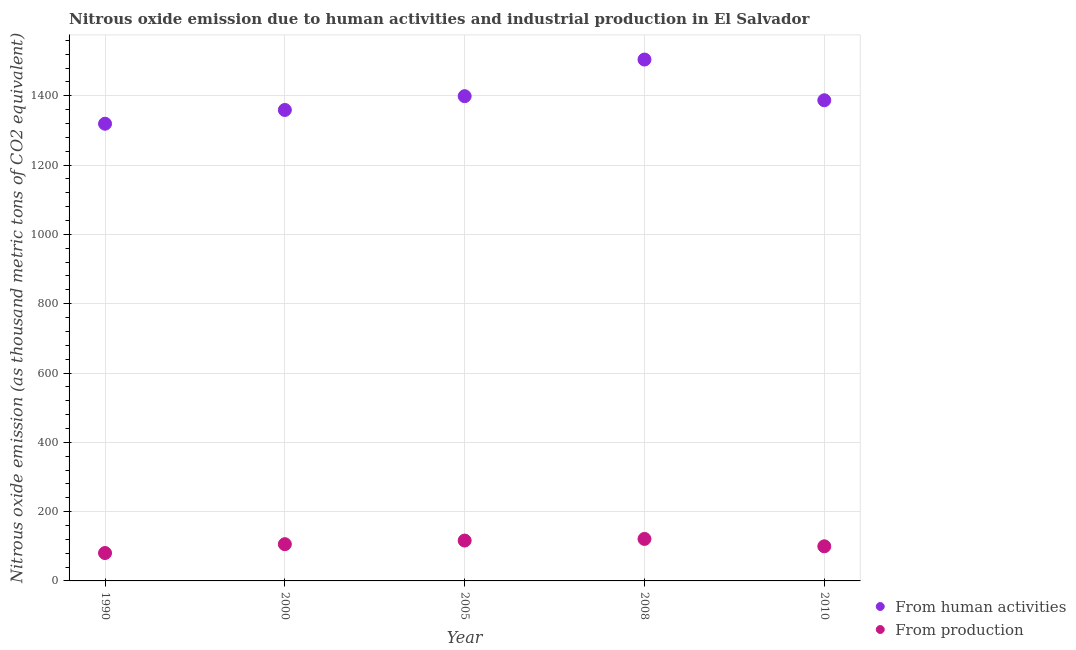Is the number of dotlines equal to the number of legend labels?
Provide a succinct answer. Yes. What is the amount of emissions generated from industries in 2010?
Your response must be concise. 99.9. Across all years, what is the maximum amount of emissions generated from industries?
Make the answer very short. 121.2. Across all years, what is the minimum amount of emissions generated from industries?
Make the answer very short. 80.5. In which year was the amount of emissions generated from industries minimum?
Keep it short and to the point. 1990. What is the total amount of emissions generated from industries in the graph?
Provide a succinct answer. 524.1. What is the difference between the amount of emissions from human activities in 2008 and that in 2010?
Make the answer very short. 117.5. What is the difference between the amount of emissions generated from industries in 2010 and the amount of emissions from human activities in 2008?
Ensure brevity in your answer.  -1404.7. What is the average amount of emissions generated from industries per year?
Make the answer very short. 104.82. In the year 2005, what is the difference between the amount of emissions from human activities and amount of emissions generated from industries?
Your response must be concise. 1282.4. What is the ratio of the amount of emissions generated from industries in 2005 to that in 2008?
Offer a terse response. 0.96. Is the amount of emissions from human activities in 1990 less than that in 2005?
Make the answer very short. Yes. What is the difference between the highest and the second highest amount of emissions generated from industries?
Your answer should be very brief. 4.7. What is the difference between the highest and the lowest amount of emissions from human activities?
Your answer should be very brief. 185.2. Is the sum of the amount of emissions generated from industries in 2005 and 2008 greater than the maximum amount of emissions from human activities across all years?
Offer a very short reply. No. Does the amount of emissions from human activities monotonically increase over the years?
Provide a short and direct response. No. Is the amount of emissions generated from industries strictly greater than the amount of emissions from human activities over the years?
Give a very brief answer. No. Is the amount of emissions from human activities strictly less than the amount of emissions generated from industries over the years?
Offer a terse response. No. How many dotlines are there?
Provide a short and direct response. 2. How many years are there in the graph?
Offer a terse response. 5. What is the difference between two consecutive major ticks on the Y-axis?
Provide a succinct answer. 200. Where does the legend appear in the graph?
Provide a short and direct response. Bottom right. How are the legend labels stacked?
Offer a terse response. Vertical. What is the title of the graph?
Provide a short and direct response. Nitrous oxide emission due to human activities and industrial production in El Salvador. What is the label or title of the Y-axis?
Keep it short and to the point. Nitrous oxide emission (as thousand metric tons of CO2 equivalent). What is the Nitrous oxide emission (as thousand metric tons of CO2 equivalent) in From human activities in 1990?
Your response must be concise. 1319.4. What is the Nitrous oxide emission (as thousand metric tons of CO2 equivalent) in From production in 1990?
Offer a terse response. 80.5. What is the Nitrous oxide emission (as thousand metric tons of CO2 equivalent) of From human activities in 2000?
Ensure brevity in your answer.  1359.1. What is the Nitrous oxide emission (as thousand metric tons of CO2 equivalent) of From production in 2000?
Provide a short and direct response. 106. What is the Nitrous oxide emission (as thousand metric tons of CO2 equivalent) in From human activities in 2005?
Your answer should be very brief. 1398.9. What is the Nitrous oxide emission (as thousand metric tons of CO2 equivalent) of From production in 2005?
Provide a succinct answer. 116.5. What is the Nitrous oxide emission (as thousand metric tons of CO2 equivalent) in From human activities in 2008?
Your answer should be compact. 1504.6. What is the Nitrous oxide emission (as thousand metric tons of CO2 equivalent) in From production in 2008?
Your response must be concise. 121.2. What is the Nitrous oxide emission (as thousand metric tons of CO2 equivalent) in From human activities in 2010?
Your answer should be compact. 1387.1. What is the Nitrous oxide emission (as thousand metric tons of CO2 equivalent) of From production in 2010?
Provide a succinct answer. 99.9. Across all years, what is the maximum Nitrous oxide emission (as thousand metric tons of CO2 equivalent) of From human activities?
Your answer should be compact. 1504.6. Across all years, what is the maximum Nitrous oxide emission (as thousand metric tons of CO2 equivalent) of From production?
Offer a terse response. 121.2. Across all years, what is the minimum Nitrous oxide emission (as thousand metric tons of CO2 equivalent) in From human activities?
Make the answer very short. 1319.4. Across all years, what is the minimum Nitrous oxide emission (as thousand metric tons of CO2 equivalent) in From production?
Ensure brevity in your answer.  80.5. What is the total Nitrous oxide emission (as thousand metric tons of CO2 equivalent) of From human activities in the graph?
Ensure brevity in your answer.  6969.1. What is the total Nitrous oxide emission (as thousand metric tons of CO2 equivalent) of From production in the graph?
Provide a succinct answer. 524.1. What is the difference between the Nitrous oxide emission (as thousand metric tons of CO2 equivalent) of From human activities in 1990 and that in 2000?
Make the answer very short. -39.7. What is the difference between the Nitrous oxide emission (as thousand metric tons of CO2 equivalent) in From production in 1990 and that in 2000?
Your answer should be compact. -25.5. What is the difference between the Nitrous oxide emission (as thousand metric tons of CO2 equivalent) of From human activities in 1990 and that in 2005?
Offer a very short reply. -79.5. What is the difference between the Nitrous oxide emission (as thousand metric tons of CO2 equivalent) of From production in 1990 and that in 2005?
Make the answer very short. -36. What is the difference between the Nitrous oxide emission (as thousand metric tons of CO2 equivalent) of From human activities in 1990 and that in 2008?
Offer a very short reply. -185.2. What is the difference between the Nitrous oxide emission (as thousand metric tons of CO2 equivalent) of From production in 1990 and that in 2008?
Keep it short and to the point. -40.7. What is the difference between the Nitrous oxide emission (as thousand metric tons of CO2 equivalent) of From human activities in 1990 and that in 2010?
Offer a terse response. -67.7. What is the difference between the Nitrous oxide emission (as thousand metric tons of CO2 equivalent) of From production in 1990 and that in 2010?
Your answer should be very brief. -19.4. What is the difference between the Nitrous oxide emission (as thousand metric tons of CO2 equivalent) of From human activities in 2000 and that in 2005?
Provide a succinct answer. -39.8. What is the difference between the Nitrous oxide emission (as thousand metric tons of CO2 equivalent) of From human activities in 2000 and that in 2008?
Ensure brevity in your answer.  -145.5. What is the difference between the Nitrous oxide emission (as thousand metric tons of CO2 equivalent) of From production in 2000 and that in 2008?
Keep it short and to the point. -15.2. What is the difference between the Nitrous oxide emission (as thousand metric tons of CO2 equivalent) in From human activities in 2000 and that in 2010?
Provide a succinct answer. -28. What is the difference between the Nitrous oxide emission (as thousand metric tons of CO2 equivalent) in From production in 2000 and that in 2010?
Your answer should be compact. 6.1. What is the difference between the Nitrous oxide emission (as thousand metric tons of CO2 equivalent) in From human activities in 2005 and that in 2008?
Give a very brief answer. -105.7. What is the difference between the Nitrous oxide emission (as thousand metric tons of CO2 equivalent) in From human activities in 2005 and that in 2010?
Give a very brief answer. 11.8. What is the difference between the Nitrous oxide emission (as thousand metric tons of CO2 equivalent) of From production in 2005 and that in 2010?
Your answer should be compact. 16.6. What is the difference between the Nitrous oxide emission (as thousand metric tons of CO2 equivalent) of From human activities in 2008 and that in 2010?
Keep it short and to the point. 117.5. What is the difference between the Nitrous oxide emission (as thousand metric tons of CO2 equivalent) of From production in 2008 and that in 2010?
Give a very brief answer. 21.3. What is the difference between the Nitrous oxide emission (as thousand metric tons of CO2 equivalent) in From human activities in 1990 and the Nitrous oxide emission (as thousand metric tons of CO2 equivalent) in From production in 2000?
Offer a very short reply. 1213.4. What is the difference between the Nitrous oxide emission (as thousand metric tons of CO2 equivalent) of From human activities in 1990 and the Nitrous oxide emission (as thousand metric tons of CO2 equivalent) of From production in 2005?
Your response must be concise. 1202.9. What is the difference between the Nitrous oxide emission (as thousand metric tons of CO2 equivalent) of From human activities in 1990 and the Nitrous oxide emission (as thousand metric tons of CO2 equivalent) of From production in 2008?
Provide a short and direct response. 1198.2. What is the difference between the Nitrous oxide emission (as thousand metric tons of CO2 equivalent) in From human activities in 1990 and the Nitrous oxide emission (as thousand metric tons of CO2 equivalent) in From production in 2010?
Provide a succinct answer. 1219.5. What is the difference between the Nitrous oxide emission (as thousand metric tons of CO2 equivalent) of From human activities in 2000 and the Nitrous oxide emission (as thousand metric tons of CO2 equivalent) of From production in 2005?
Offer a very short reply. 1242.6. What is the difference between the Nitrous oxide emission (as thousand metric tons of CO2 equivalent) in From human activities in 2000 and the Nitrous oxide emission (as thousand metric tons of CO2 equivalent) in From production in 2008?
Provide a succinct answer. 1237.9. What is the difference between the Nitrous oxide emission (as thousand metric tons of CO2 equivalent) of From human activities in 2000 and the Nitrous oxide emission (as thousand metric tons of CO2 equivalent) of From production in 2010?
Your response must be concise. 1259.2. What is the difference between the Nitrous oxide emission (as thousand metric tons of CO2 equivalent) of From human activities in 2005 and the Nitrous oxide emission (as thousand metric tons of CO2 equivalent) of From production in 2008?
Provide a short and direct response. 1277.7. What is the difference between the Nitrous oxide emission (as thousand metric tons of CO2 equivalent) of From human activities in 2005 and the Nitrous oxide emission (as thousand metric tons of CO2 equivalent) of From production in 2010?
Ensure brevity in your answer.  1299. What is the difference between the Nitrous oxide emission (as thousand metric tons of CO2 equivalent) of From human activities in 2008 and the Nitrous oxide emission (as thousand metric tons of CO2 equivalent) of From production in 2010?
Offer a very short reply. 1404.7. What is the average Nitrous oxide emission (as thousand metric tons of CO2 equivalent) in From human activities per year?
Offer a very short reply. 1393.82. What is the average Nitrous oxide emission (as thousand metric tons of CO2 equivalent) in From production per year?
Your answer should be compact. 104.82. In the year 1990, what is the difference between the Nitrous oxide emission (as thousand metric tons of CO2 equivalent) of From human activities and Nitrous oxide emission (as thousand metric tons of CO2 equivalent) of From production?
Make the answer very short. 1238.9. In the year 2000, what is the difference between the Nitrous oxide emission (as thousand metric tons of CO2 equivalent) in From human activities and Nitrous oxide emission (as thousand metric tons of CO2 equivalent) in From production?
Make the answer very short. 1253.1. In the year 2005, what is the difference between the Nitrous oxide emission (as thousand metric tons of CO2 equivalent) of From human activities and Nitrous oxide emission (as thousand metric tons of CO2 equivalent) of From production?
Keep it short and to the point. 1282.4. In the year 2008, what is the difference between the Nitrous oxide emission (as thousand metric tons of CO2 equivalent) of From human activities and Nitrous oxide emission (as thousand metric tons of CO2 equivalent) of From production?
Provide a succinct answer. 1383.4. In the year 2010, what is the difference between the Nitrous oxide emission (as thousand metric tons of CO2 equivalent) in From human activities and Nitrous oxide emission (as thousand metric tons of CO2 equivalent) in From production?
Your answer should be very brief. 1287.2. What is the ratio of the Nitrous oxide emission (as thousand metric tons of CO2 equivalent) in From human activities in 1990 to that in 2000?
Give a very brief answer. 0.97. What is the ratio of the Nitrous oxide emission (as thousand metric tons of CO2 equivalent) of From production in 1990 to that in 2000?
Offer a very short reply. 0.76. What is the ratio of the Nitrous oxide emission (as thousand metric tons of CO2 equivalent) of From human activities in 1990 to that in 2005?
Make the answer very short. 0.94. What is the ratio of the Nitrous oxide emission (as thousand metric tons of CO2 equivalent) of From production in 1990 to that in 2005?
Ensure brevity in your answer.  0.69. What is the ratio of the Nitrous oxide emission (as thousand metric tons of CO2 equivalent) of From human activities in 1990 to that in 2008?
Offer a terse response. 0.88. What is the ratio of the Nitrous oxide emission (as thousand metric tons of CO2 equivalent) in From production in 1990 to that in 2008?
Keep it short and to the point. 0.66. What is the ratio of the Nitrous oxide emission (as thousand metric tons of CO2 equivalent) in From human activities in 1990 to that in 2010?
Offer a terse response. 0.95. What is the ratio of the Nitrous oxide emission (as thousand metric tons of CO2 equivalent) in From production in 1990 to that in 2010?
Offer a very short reply. 0.81. What is the ratio of the Nitrous oxide emission (as thousand metric tons of CO2 equivalent) of From human activities in 2000 to that in 2005?
Your response must be concise. 0.97. What is the ratio of the Nitrous oxide emission (as thousand metric tons of CO2 equivalent) in From production in 2000 to that in 2005?
Keep it short and to the point. 0.91. What is the ratio of the Nitrous oxide emission (as thousand metric tons of CO2 equivalent) of From human activities in 2000 to that in 2008?
Offer a very short reply. 0.9. What is the ratio of the Nitrous oxide emission (as thousand metric tons of CO2 equivalent) of From production in 2000 to that in 2008?
Your answer should be very brief. 0.87. What is the ratio of the Nitrous oxide emission (as thousand metric tons of CO2 equivalent) in From human activities in 2000 to that in 2010?
Your response must be concise. 0.98. What is the ratio of the Nitrous oxide emission (as thousand metric tons of CO2 equivalent) of From production in 2000 to that in 2010?
Ensure brevity in your answer.  1.06. What is the ratio of the Nitrous oxide emission (as thousand metric tons of CO2 equivalent) of From human activities in 2005 to that in 2008?
Your answer should be very brief. 0.93. What is the ratio of the Nitrous oxide emission (as thousand metric tons of CO2 equivalent) of From production in 2005 to that in 2008?
Your answer should be very brief. 0.96. What is the ratio of the Nitrous oxide emission (as thousand metric tons of CO2 equivalent) of From human activities in 2005 to that in 2010?
Provide a short and direct response. 1.01. What is the ratio of the Nitrous oxide emission (as thousand metric tons of CO2 equivalent) of From production in 2005 to that in 2010?
Provide a succinct answer. 1.17. What is the ratio of the Nitrous oxide emission (as thousand metric tons of CO2 equivalent) of From human activities in 2008 to that in 2010?
Offer a very short reply. 1.08. What is the ratio of the Nitrous oxide emission (as thousand metric tons of CO2 equivalent) in From production in 2008 to that in 2010?
Your answer should be very brief. 1.21. What is the difference between the highest and the second highest Nitrous oxide emission (as thousand metric tons of CO2 equivalent) in From human activities?
Your answer should be compact. 105.7. What is the difference between the highest and the lowest Nitrous oxide emission (as thousand metric tons of CO2 equivalent) of From human activities?
Ensure brevity in your answer.  185.2. What is the difference between the highest and the lowest Nitrous oxide emission (as thousand metric tons of CO2 equivalent) in From production?
Offer a very short reply. 40.7. 